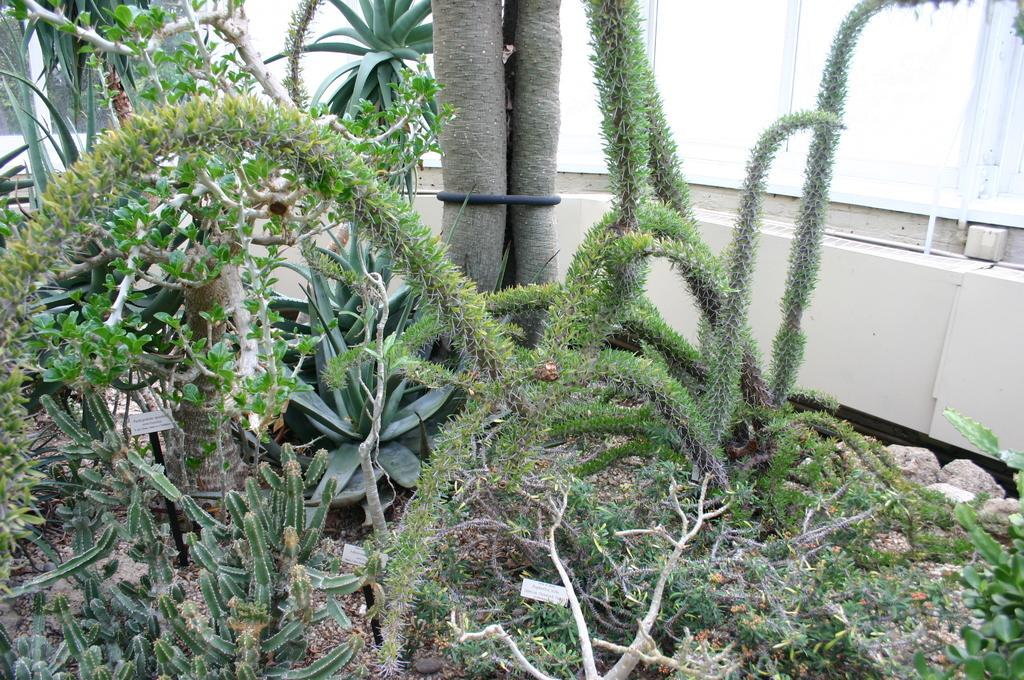What type of plants are in the image? There are cactus plants in the image. What can be seen in the background of the image? There are plants and a wall in the background of the image. What color is the wall in the background? The wall is cream in color. What architectural feature is present in the background of the image? There is a window in the background of the image. What type of corn can be seen growing near the cactus plants in the image? There is no corn present in the image; it only features cactus plants, plants, a wall, and a window in the background. 